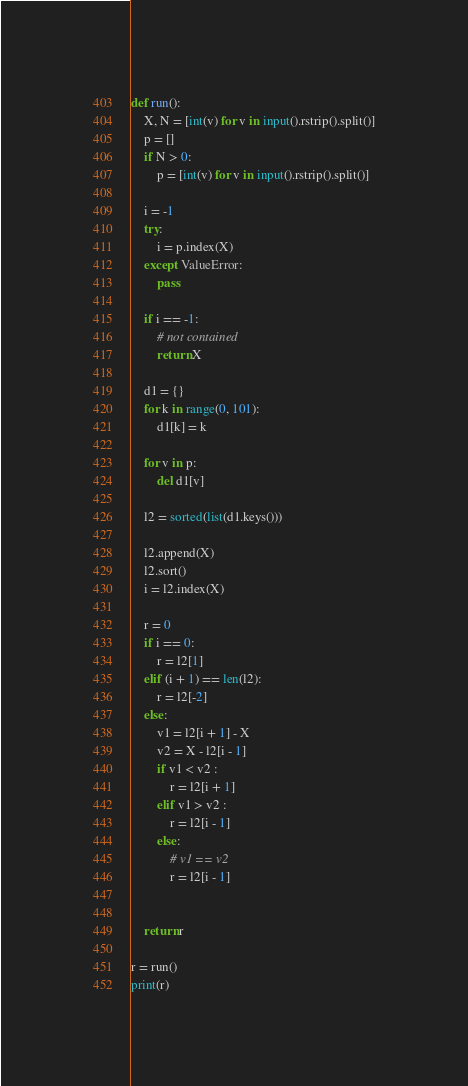Convert code to text. <code><loc_0><loc_0><loc_500><loc_500><_Python_>def run():
	X, N = [int(v) for v in input().rstrip().split()]
	p = []
	if N > 0:
		p = [int(v) for v in input().rstrip().split()]

	i = -1
	try:
		i = p.index(X)
	except ValueError:
		pass

	if i == -1:
		# not contained	
		return X

	d1 = {}
	for k in range(0, 101):
		d1[k] = k

	for v in p:
		del d1[v]

	l2 = sorted(list(d1.keys()))

	l2.append(X)
	l2.sort()
	i = l2.index(X)

	r = 0
	if i == 0:
		r = l2[1]
	elif (i + 1) == len(l2):
		r = l2[-2]
	else:
		v1 = l2[i + 1] - X
		v2 = X - l2[i - 1]
		if v1 < v2 :
			r = l2[i + 1]
		elif v1 > v2 :
			r = l2[i - 1]
		else:
			# v1 == v2
			r = l2[i - 1]


	return r

r = run()
print(r)

</code> 